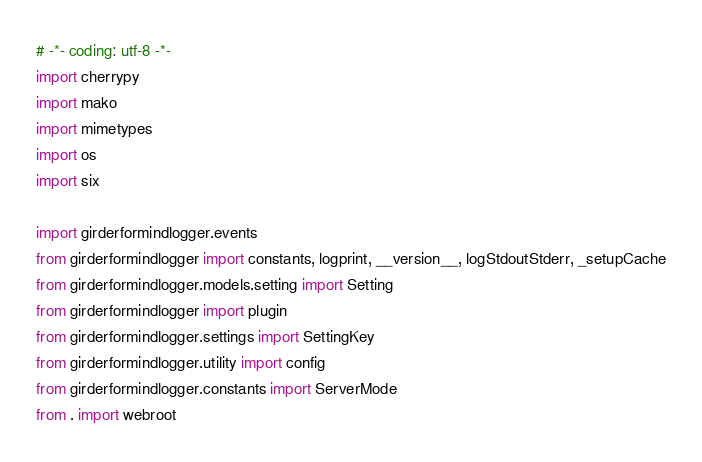Convert code to text. <code><loc_0><loc_0><loc_500><loc_500><_Python_># -*- coding: utf-8 -*-
import cherrypy
import mako
import mimetypes
import os
import six

import girderformindlogger.events
from girderformindlogger import constants, logprint, __version__, logStdoutStderr, _setupCache
from girderformindlogger.models.setting import Setting
from girderformindlogger import plugin
from girderformindlogger.settings import SettingKey
from girderformindlogger.utility import config
from girderformindlogger.constants import ServerMode
from . import webroot
</code> 